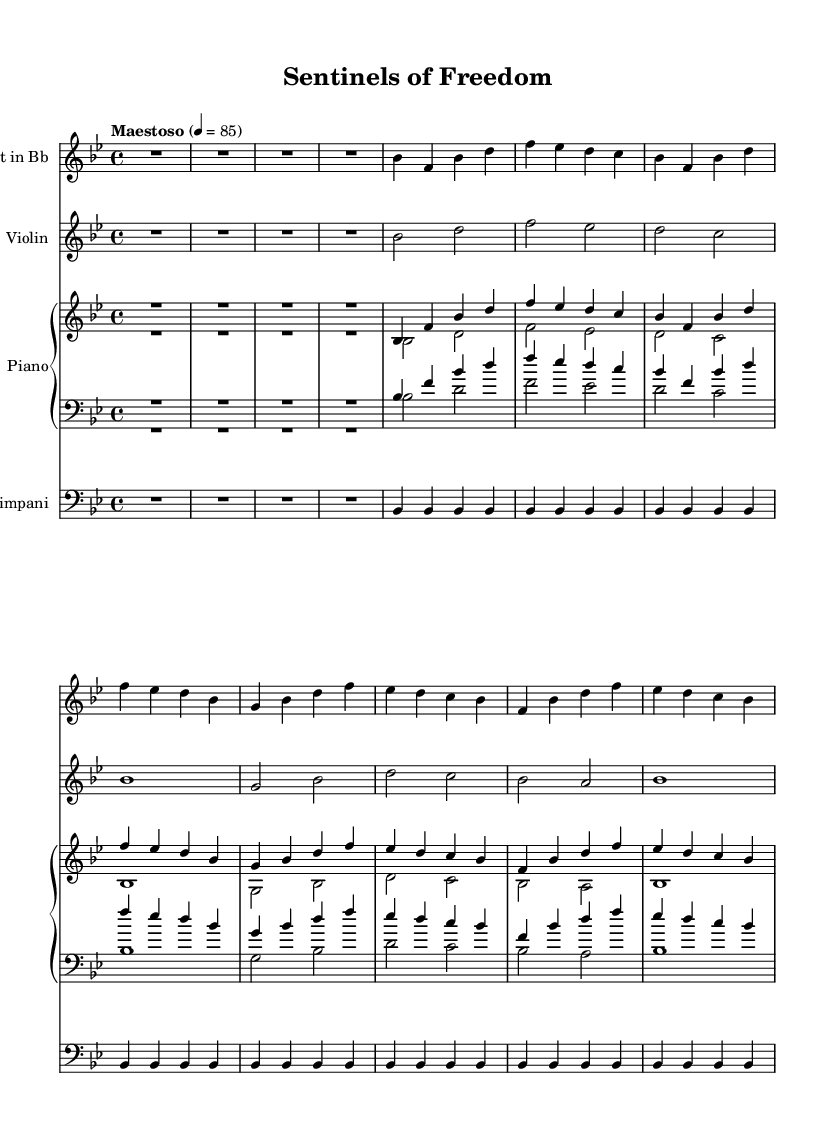What is the key signature of this music? The key signature is represented by the flat symbol, indicating the notes that will be flattened. In this case, it has two flats (B flat and E flat).
Answer: B flat major What is the time signature of this piece? The time signature is denoted at the beginning of the score by the numbers showing the number of beats per measure and the note value that gets one beat. Here, it shows 4 over 4.
Answer: 4/4 What is the tempo marking of this composition? The tempo marking is indicated in Italian at the beginning of the score, specifying the speed of the piece. In this case, it is marked as "Maestoso" with a metronome marking of quarter note = 85.
Answer: Maestoso How many measures does the trumpet part contain? To determine this, one counts the number of horizontal lines in the trumpet staff, which represent measures. The trumpet part has eight measures.
Answer: 8 Which instruments are included in this score? The instruments are listed in the score, and we then count them: Trumpet, Violin, Piano (which has two staves, upper and lower), and Timpani, totaling four distinct parts.
Answer: Trumpet, Violin, Piano, Timpani What is the rhythmic pattern of the timpani part? The timpani part consists of only one note throughout the measures, represented as a repeated single note with a specific rhythmic duration depicted. It consistently plays a quarter note for each of the eight measures.
Answer: Repeated quarter note 